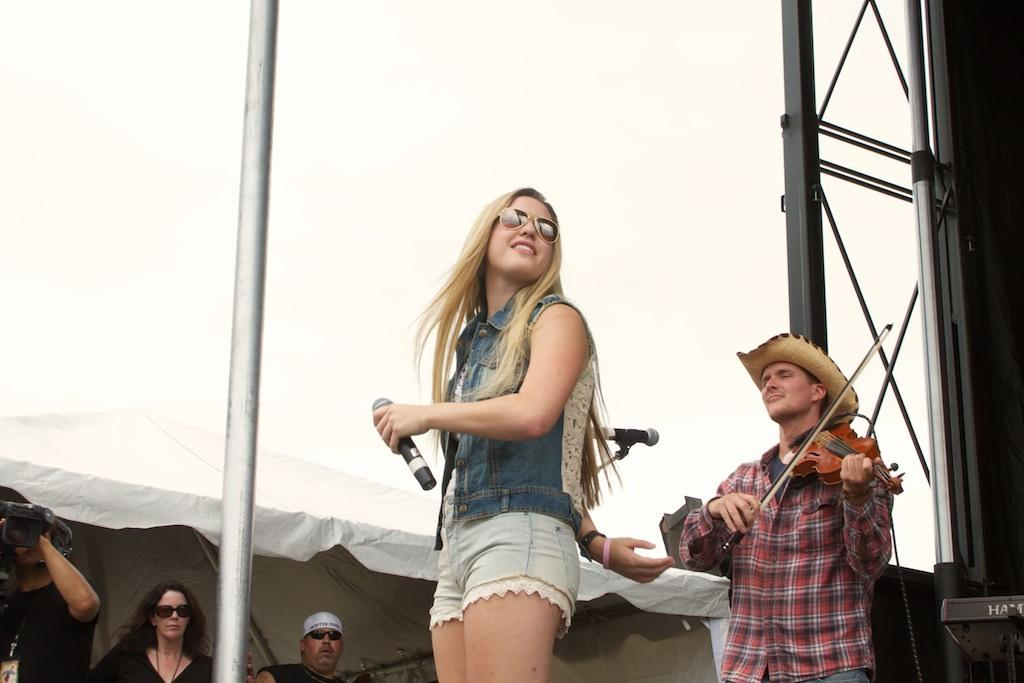How many people are in the image? There are people in the image, but the exact number is not specified. What is the woman holding in the image? The woman is holding a microphone. What instrument is being played by one of the people in the image? A person is playing a guitar. Where are some of the people located in the image? Some people are in a shed. What type of garden can be seen in the image? There is no garden present in the image. How does the wealth of the people in the image compare to the average person? The facts provided do not give any information about the wealth of the people in the image, so it cannot be compared to the average person. 